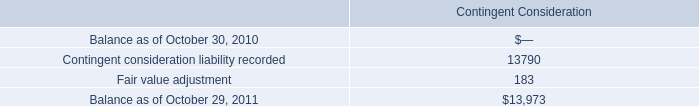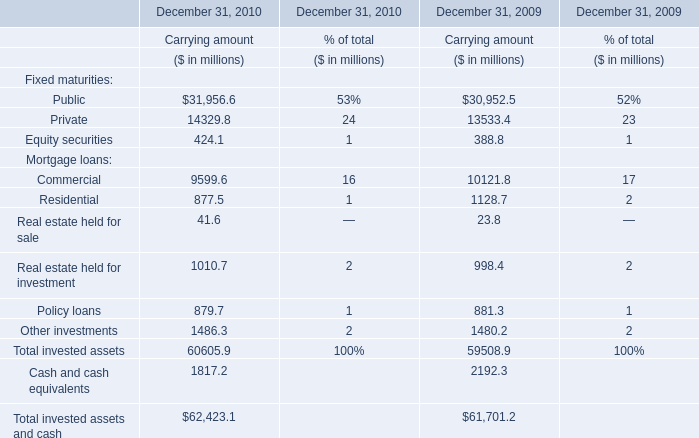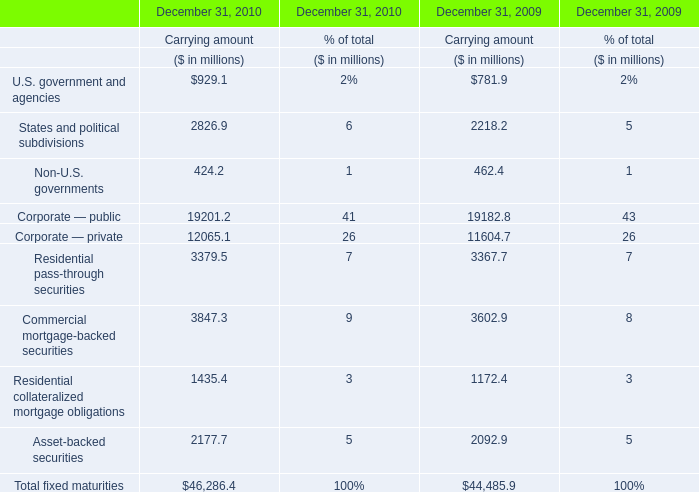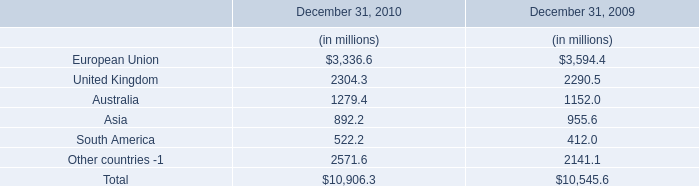If Other investments develops with the same growth rate in 2010, what will it reach in 2011? (in million) 
Computations: (1486.3 * (1 + ((1486.3 - 1480.20) / 1480.2)))
Answer: 1492.42514. 